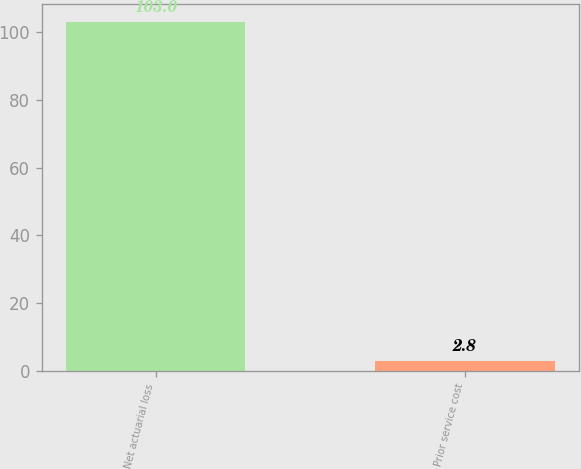Convert chart. <chart><loc_0><loc_0><loc_500><loc_500><bar_chart><fcel>Net actuarial loss<fcel>Prior service cost<nl><fcel>103<fcel>2.8<nl></chart> 